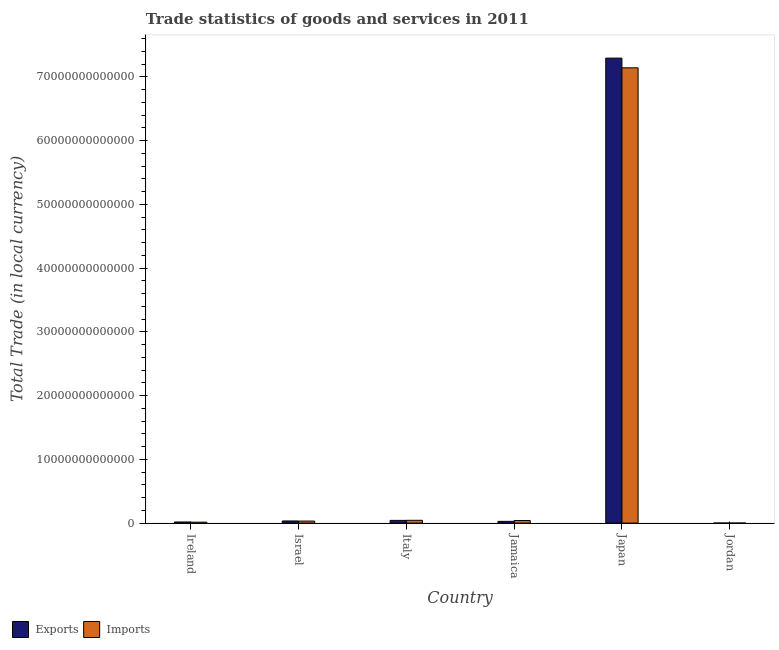How many groups of bars are there?
Provide a short and direct response. 6. Are the number of bars per tick equal to the number of legend labels?
Provide a short and direct response. Yes. Are the number of bars on each tick of the X-axis equal?
Keep it short and to the point. Yes. How many bars are there on the 5th tick from the left?
Provide a succinct answer. 2. How many bars are there on the 3rd tick from the right?
Provide a short and direct response. 2. What is the export of goods and services in Italy?
Give a very brief answer. 4.25e+11. Across all countries, what is the maximum export of goods and services?
Provide a short and direct response. 7.29e+13. Across all countries, what is the minimum imports of goods and services?
Offer a terse response. 5.17e+09. In which country was the export of goods and services maximum?
Give a very brief answer. Japan. In which country was the imports of goods and services minimum?
Provide a succinct answer. Jordan. What is the total imports of goods and services in the graph?
Your response must be concise. 7.27e+13. What is the difference between the export of goods and services in Ireland and that in Japan?
Keep it short and to the point. -7.27e+13. What is the difference between the imports of goods and services in Italy and the export of goods and services in Japan?
Provide a short and direct response. -7.25e+13. What is the average export of goods and services per country?
Ensure brevity in your answer.  1.24e+13. What is the difference between the imports of goods and services and export of goods and services in Japan?
Offer a terse response. -1.52e+12. What is the ratio of the export of goods and services in Israel to that in Japan?
Ensure brevity in your answer.  0. Is the imports of goods and services in Jamaica less than that in Japan?
Keep it short and to the point. Yes. What is the difference between the highest and the second highest export of goods and services?
Offer a very short reply. 7.25e+13. What is the difference between the highest and the lowest imports of goods and services?
Keep it short and to the point. 7.14e+13. Is the sum of the imports of goods and services in Italy and Jamaica greater than the maximum export of goods and services across all countries?
Offer a terse response. No. What does the 2nd bar from the left in Italy represents?
Your response must be concise. Imports. What does the 2nd bar from the right in Ireland represents?
Provide a succinct answer. Exports. Are all the bars in the graph horizontal?
Your response must be concise. No. How many countries are there in the graph?
Give a very brief answer. 6. What is the difference between two consecutive major ticks on the Y-axis?
Keep it short and to the point. 1.00e+13. Are the values on the major ticks of Y-axis written in scientific E-notation?
Offer a terse response. No. Does the graph contain any zero values?
Offer a very short reply. No. Does the graph contain grids?
Your response must be concise. No. How many legend labels are there?
Make the answer very short. 2. What is the title of the graph?
Make the answer very short. Trade statistics of goods and services in 2011. Does "Non-resident workers" appear as one of the legend labels in the graph?
Make the answer very short. No. What is the label or title of the Y-axis?
Offer a terse response. Total Trade (in local currency). What is the Total Trade (in local currency) in Exports in Ireland?
Offer a very short reply. 1.75e+11. What is the Total Trade (in local currency) in Imports in Ireland?
Give a very brief answer. 1.43e+11. What is the Total Trade (in local currency) of Exports in Israel?
Offer a very short reply. 3.34e+11. What is the Total Trade (in local currency) of Imports in Israel?
Offer a very short reply. 3.17e+11. What is the Total Trade (in local currency) of Exports in Italy?
Your answer should be compact. 4.25e+11. What is the Total Trade (in local currency) in Imports in Italy?
Offer a terse response. 4.38e+11. What is the Total Trade (in local currency) of Exports in Jamaica?
Provide a succinct answer. 2.71e+11. What is the Total Trade (in local currency) of Imports in Jamaica?
Make the answer very short. 4.09e+11. What is the Total Trade (in local currency) of Exports in Japan?
Ensure brevity in your answer.  7.29e+13. What is the Total Trade (in local currency) in Imports in Japan?
Ensure brevity in your answer.  7.14e+13. What is the Total Trade (in local currency) in Exports in Jordan?
Ensure brevity in your answer.  4.31e+09. What is the Total Trade (in local currency) of Imports in Jordan?
Provide a short and direct response. 5.17e+09. Across all countries, what is the maximum Total Trade (in local currency) of Exports?
Give a very brief answer. 7.29e+13. Across all countries, what is the maximum Total Trade (in local currency) in Imports?
Keep it short and to the point. 7.14e+13. Across all countries, what is the minimum Total Trade (in local currency) in Exports?
Offer a terse response. 4.31e+09. Across all countries, what is the minimum Total Trade (in local currency) of Imports?
Offer a very short reply. 5.17e+09. What is the total Total Trade (in local currency) of Exports in the graph?
Give a very brief answer. 7.41e+13. What is the total Total Trade (in local currency) in Imports in the graph?
Your answer should be compact. 7.27e+13. What is the difference between the Total Trade (in local currency) in Exports in Ireland and that in Israel?
Your answer should be very brief. -1.59e+11. What is the difference between the Total Trade (in local currency) in Imports in Ireland and that in Israel?
Your answer should be compact. -1.75e+11. What is the difference between the Total Trade (in local currency) of Exports in Ireland and that in Italy?
Ensure brevity in your answer.  -2.50e+11. What is the difference between the Total Trade (in local currency) in Imports in Ireland and that in Italy?
Ensure brevity in your answer.  -2.95e+11. What is the difference between the Total Trade (in local currency) in Exports in Ireland and that in Jamaica?
Make the answer very short. -9.64e+1. What is the difference between the Total Trade (in local currency) in Imports in Ireland and that in Jamaica?
Provide a short and direct response. -2.66e+11. What is the difference between the Total Trade (in local currency) in Exports in Ireland and that in Japan?
Ensure brevity in your answer.  -7.27e+13. What is the difference between the Total Trade (in local currency) in Imports in Ireland and that in Japan?
Your response must be concise. -7.13e+13. What is the difference between the Total Trade (in local currency) of Exports in Ireland and that in Jordan?
Offer a terse response. 1.71e+11. What is the difference between the Total Trade (in local currency) of Imports in Ireland and that in Jordan?
Ensure brevity in your answer.  1.37e+11. What is the difference between the Total Trade (in local currency) of Exports in Israel and that in Italy?
Keep it short and to the point. -9.09e+1. What is the difference between the Total Trade (in local currency) of Imports in Israel and that in Italy?
Provide a succinct answer. -1.21e+11. What is the difference between the Total Trade (in local currency) of Exports in Israel and that in Jamaica?
Your response must be concise. 6.28e+1. What is the difference between the Total Trade (in local currency) in Imports in Israel and that in Jamaica?
Keep it short and to the point. -9.18e+1. What is the difference between the Total Trade (in local currency) in Exports in Israel and that in Japan?
Offer a very short reply. -7.26e+13. What is the difference between the Total Trade (in local currency) of Imports in Israel and that in Japan?
Your answer should be compact. -7.11e+13. What is the difference between the Total Trade (in local currency) of Exports in Israel and that in Jordan?
Keep it short and to the point. 3.30e+11. What is the difference between the Total Trade (in local currency) in Imports in Israel and that in Jordan?
Make the answer very short. 3.12e+11. What is the difference between the Total Trade (in local currency) of Exports in Italy and that in Jamaica?
Give a very brief answer. 1.54e+11. What is the difference between the Total Trade (in local currency) in Imports in Italy and that in Jamaica?
Provide a short and direct response. 2.91e+1. What is the difference between the Total Trade (in local currency) of Exports in Italy and that in Japan?
Offer a very short reply. -7.25e+13. What is the difference between the Total Trade (in local currency) in Imports in Italy and that in Japan?
Offer a terse response. -7.10e+13. What is the difference between the Total Trade (in local currency) in Exports in Italy and that in Jordan?
Ensure brevity in your answer.  4.21e+11. What is the difference between the Total Trade (in local currency) of Imports in Italy and that in Jordan?
Your answer should be compact. 4.33e+11. What is the difference between the Total Trade (in local currency) in Exports in Jamaica and that in Japan?
Provide a succinct answer. -7.27e+13. What is the difference between the Total Trade (in local currency) of Imports in Jamaica and that in Japan?
Your answer should be compact. -7.10e+13. What is the difference between the Total Trade (in local currency) of Exports in Jamaica and that in Jordan?
Keep it short and to the point. 2.67e+11. What is the difference between the Total Trade (in local currency) in Imports in Jamaica and that in Jordan?
Offer a very short reply. 4.04e+11. What is the difference between the Total Trade (in local currency) of Exports in Japan and that in Jordan?
Make the answer very short. 7.29e+13. What is the difference between the Total Trade (in local currency) of Imports in Japan and that in Jordan?
Your answer should be very brief. 7.14e+13. What is the difference between the Total Trade (in local currency) in Exports in Ireland and the Total Trade (in local currency) in Imports in Israel?
Make the answer very short. -1.42e+11. What is the difference between the Total Trade (in local currency) in Exports in Ireland and the Total Trade (in local currency) in Imports in Italy?
Give a very brief answer. -2.63e+11. What is the difference between the Total Trade (in local currency) in Exports in Ireland and the Total Trade (in local currency) in Imports in Jamaica?
Give a very brief answer. -2.34e+11. What is the difference between the Total Trade (in local currency) in Exports in Ireland and the Total Trade (in local currency) in Imports in Japan?
Offer a terse response. -7.12e+13. What is the difference between the Total Trade (in local currency) in Exports in Ireland and the Total Trade (in local currency) in Imports in Jordan?
Your answer should be very brief. 1.70e+11. What is the difference between the Total Trade (in local currency) in Exports in Israel and the Total Trade (in local currency) in Imports in Italy?
Give a very brief answer. -1.04e+11. What is the difference between the Total Trade (in local currency) in Exports in Israel and the Total Trade (in local currency) in Imports in Jamaica?
Your answer should be very brief. -7.48e+1. What is the difference between the Total Trade (in local currency) of Exports in Israel and the Total Trade (in local currency) of Imports in Japan?
Keep it short and to the point. -7.11e+13. What is the difference between the Total Trade (in local currency) of Exports in Israel and the Total Trade (in local currency) of Imports in Jordan?
Offer a terse response. 3.29e+11. What is the difference between the Total Trade (in local currency) of Exports in Italy and the Total Trade (in local currency) of Imports in Jamaica?
Provide a short and direct response. 1.61e+1. What is the difference between the Total Trade (in local currency) of Exports in Italy and the Total Trade (in local currency) of Imports in Japan?
Keep it short and to the point. -7.10e+13. What is the difference between the Total Trade (in local currency) in Exports in Italy and the Total Trade (in local currency) in Imports in Jordan?
Offer a very short reply. 4.20e+11. What is the difference between the Total Trade (in local currency) in Exports in Jamaica and the Total Trade (in local currency) in Imports in Japan?
Offer a terse response. -7.11e+13. What is the difference between the Total Trade (in local currency) in Exports in Jamaica and the Total Trade (in local currency) in Imports in Jordan?
Keep it short and to the point. 2.66e+11. What is the difference between the Total Trade (in local currency) of Exports in Japan and the Total Trade (in local currency) of Imports in Jordan?
Offer a terse response. 7.29e+13. What is the average Total Trade (in local currency) in Exports per country?
Your response must be concise. 1.24e+13. What is the average Total Trade (in local currency) in Imports per country?
Keep it short and to the point. 1.21e+13. What is the difference between the Total Trade (in local currency) of Exports and Total Trade (in local currency) of Imports in Ireland?
Offer a terse response. 3.24e+1. What is the difference between the Total Trade (in local currency) in Exports and Total Trade (in local currency) in Imports in Israel?
Offer a terse response. 1.70e+1. What is the difference between the Total Trade (in local currency) of Exports and Total Trade (in local currency) of Imports in Italy?
Provide a succinct answer. -1.29e+1. What is the difference between the Total Trade (in local currency) of Exports and Total Trade (in local currency) of Imports in Jamaica?
Make the answer very short. -1.38e+11. What is the difference between the Total Trade (in local currency) of Exports and Total Trade (in local currency) of Imports in Japan?
Your response must be concise. 1.52e+12. What is the difference between the Total Trade (in local currency) of Exports and Total Trade (in local currency) of Imports in Jordan?
Ensure brevity in your answer.  -8.67e+08. What is the ratio of the Total Trade (in local currency) of Exports in Ireland to that in Israel?
Provide a short and direct response. 0.52. What is the ratio of the Total Trade (in local currency) in Imports in Ireland to that in Israel?
Your answer should be very brief. 0.45. What is the ratio of the Total Trade (in local currency) in Exports in Ireland to that in Italy?
Offer a very short reply. 0.41. What is the ratio of the Total Trade (in local currency) in Imports in Ireland to that in Italy?
Your answer should be very brief. 0.33. What is the ratio of the Total Trade (in local currency) of Exports in Ireland to that in Jamaica?
Give a very brief answer. 0.64. What is the ratio of the Total Trade (in local currency) in Imports in Ireland to that in Jamaica?
Keep it short and to the point. 0.35. What is the ratio of the Total Trade (in local currency) in Exports in Ireland to that in Japan?
Provide a succinct answer. 0. What is the ratio of the Total Trade (in local currency) in Imports in Ireland to that in Japan?
Give a very brief answer. 0. What is the ratio of the Total Trade (in local currency) of Exports in Ireland to that in Jordan?
Offer a very short reply. 40.63. What is the ratio of the Total Trade (in local currency) of Imports in Ireland to that in Jordan?
Ensure brevity in your answer.  27.56. What is the ratio of the Total Trade (in local currency) of Exports in Israel to that in Italy?
Your response must be concise. 0.79. What is the ratio of the Total Trade (in local currency) of Imports in Israel to that in Italy?
Your answer should be compact. 0.72. What is the ratio of the Total Trade (in local currency) of Exports in Israel to that in Jamaica?
Your response must be concise. 1.23. What is the ratio of the Total Trade (in local currency) of Imports in Israel to that in Jamaica?
Offer a very short reply. 0.78. What is the ratio of the Total Trade (in local currency) in Exports in Israel to that in Japan?
Make the answer very short. 0. What is the ratio of the Total Trade (in local currency) of Imports in Israel to that in Japan?
Your answer should be very brief. 0. What is the ratio of the Total Trade (in local currency) of Exports in Israel to that in Jordan?
Provide a short and direct response. 77.6. What is the ratio of the Total Trade (in local currency) in Imports in Israel to that in Jordan?
Your answer should be very brief. 61.31. What is the ratio of the Total Trade (in local currency) in Exports in Italy to that in Jamaica?
Offer a terse response. 1.57. What is the ratio of the Total Trade (in local currency) of Imports in Italy to that in Jamaica?
Provide a succinct answer. 1.07. What is the ratio of the Total Trade (in local currency) of Exports in Italy to that in Japan?
Offer a terse response. 0.01. What is the ratio of the Total Trade (in local currency) of Imports in Italy to that in Japan?
Your answer should be compact. 0.01. What is the ratio of the Total Trade (in local currency) in Exports in Italy to that in Jordan?
Make the answer very short. 98.7. What is the ratio of the Total Trade (in local currency) of Imports in Italy to that in Jordan?
Your answer should be compact. 84.67. What is the ratio of the Total Trade (in local currency) in Exports in Jamaica to that in Japan?
Offer a terse response. 0. What is the ratio of the Total Trade (in local currency) in Imports in Jamaica to that in Japan?
Give a very brief answer. 0.01. What is the ratio of the Total Trade (in local currency) in Exports in Jamaica to that in Jordan?
Offer a very short reply. 63.01. What is the ratio of the Total Trade (in local currency) of Imports in Jamaica to that in Jordan?
Your answer should be very brief. 79.05. What is the ratio of the Total Trade (in local currency) of Exports in Japan to that in Jordan?
Your answer should be compact. 1.69e+04. What is the ratio of the Total Trade (in local currency) of Imports in Japan to that in Jordan?
Your response must be concise. 1.38e+04. What is the difference between the highest and the second highest Total Trade (in local currency) in Exports?
Keep it short and to the point. 7.25e+13. What is the difference between the highest and the second highest Total Trade (in local currency) of Imports?
Keep it short and to the point. 7.10e+13. What is the difference between the highest and the lowest Total Trade (in local currency) in Exports?
Provide a short and direct response. 7.29e+13. What is the difference between the highest and the lowest Total Trade (in local currency) in Imports?
Your answer should be compact. 7.14e+13. 